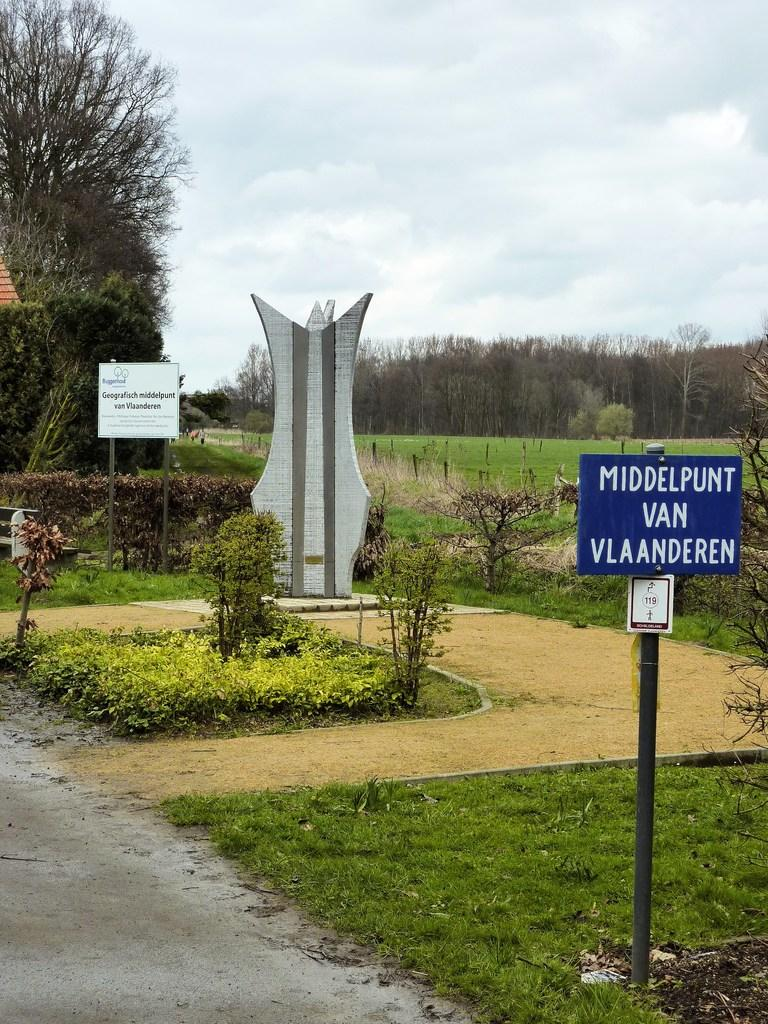What is the main subject in the image? There is a statue in the image. What type of natural elements can be seen in the image? There are trees, grass, and plants visible in the image. What man-made structures are present in the image? There are poles and boards with text in the image. What can be seen in the background of the image? The sky with clouds is visible in the background of the image. Can you tell me how many friends are standing next to the statue in the image? There is no mention of friends or any people in the image; it only features a statue, trees, poles, boards with text, grass, plants, and the sky with clouds. 